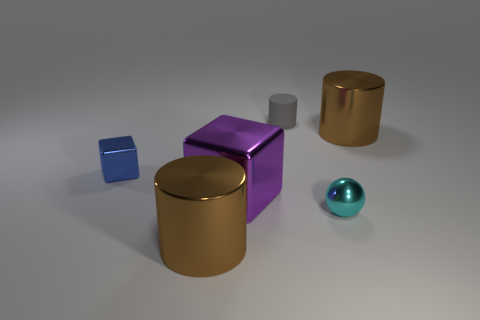What color is the small object that is behind the large brown thing right of the small gray matte cylinder?
Make the answer very short. Gray. Is there another large block that has the same color as the large shiny cube?
Your response must be concise. No. There is a rubber thing that is the same size as the ball; what is its shape?
Offer a very short reply. Cylinder. What number of large purple things are left of the large brown object that is to the left of the cyan sphere?
Make the answer very short. 0. Do the small rubber cylinder and the shiny sphere have the same color?
Offer a very short reply. No. How many other objects are there of the same material as the tiny block?
Ensure brevity in your answer.  4. There is a large brown object that is behind the brown object that is to the left of the cyan sphere; what shape is it?
Your response must be concise. Cylinder. What size is the brown cylinder right of the small cyan metallic sphere?
Your answer should be very brief. Large. Is the material of the gray thing the same as the purple cube?
Ensure brevity in your answer.  No. What is the shape of the purple thing that is made of the same material as the blue thing?
Ensure brevity in your answer.  Cube. 